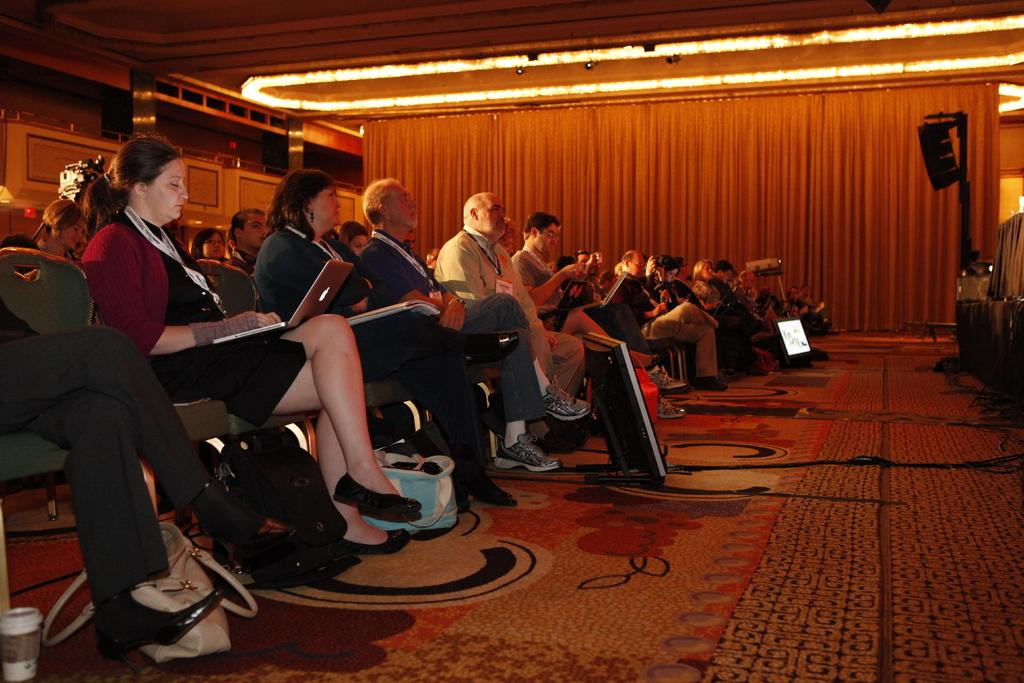What are the persons in the image doing? The persons in the image are sitting on chairs. What is in front of the persons? There is a screen in front of the persons. What type of covering can be seen in the image? There is a curtain visible in the image. What can be used for illumination in the image? There are lights in the image. What type of hat is the person wearing in the image? There is no person wearing a hat in the image. What kind of waves can be seen in the image? There are no waves present in the image. 